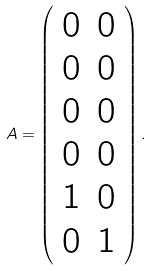Convert formula to latex. <formula><loc_0><loc_0><loc_500><loc_500>A = \left ( \begin{array} { c c } 0 & 0 \\ 0 & 0 \\ 0 & 0 \\ 0 & 0 \\ 1 & 0 \\ 0 & 1 \end{array} \right ) .</formula> 